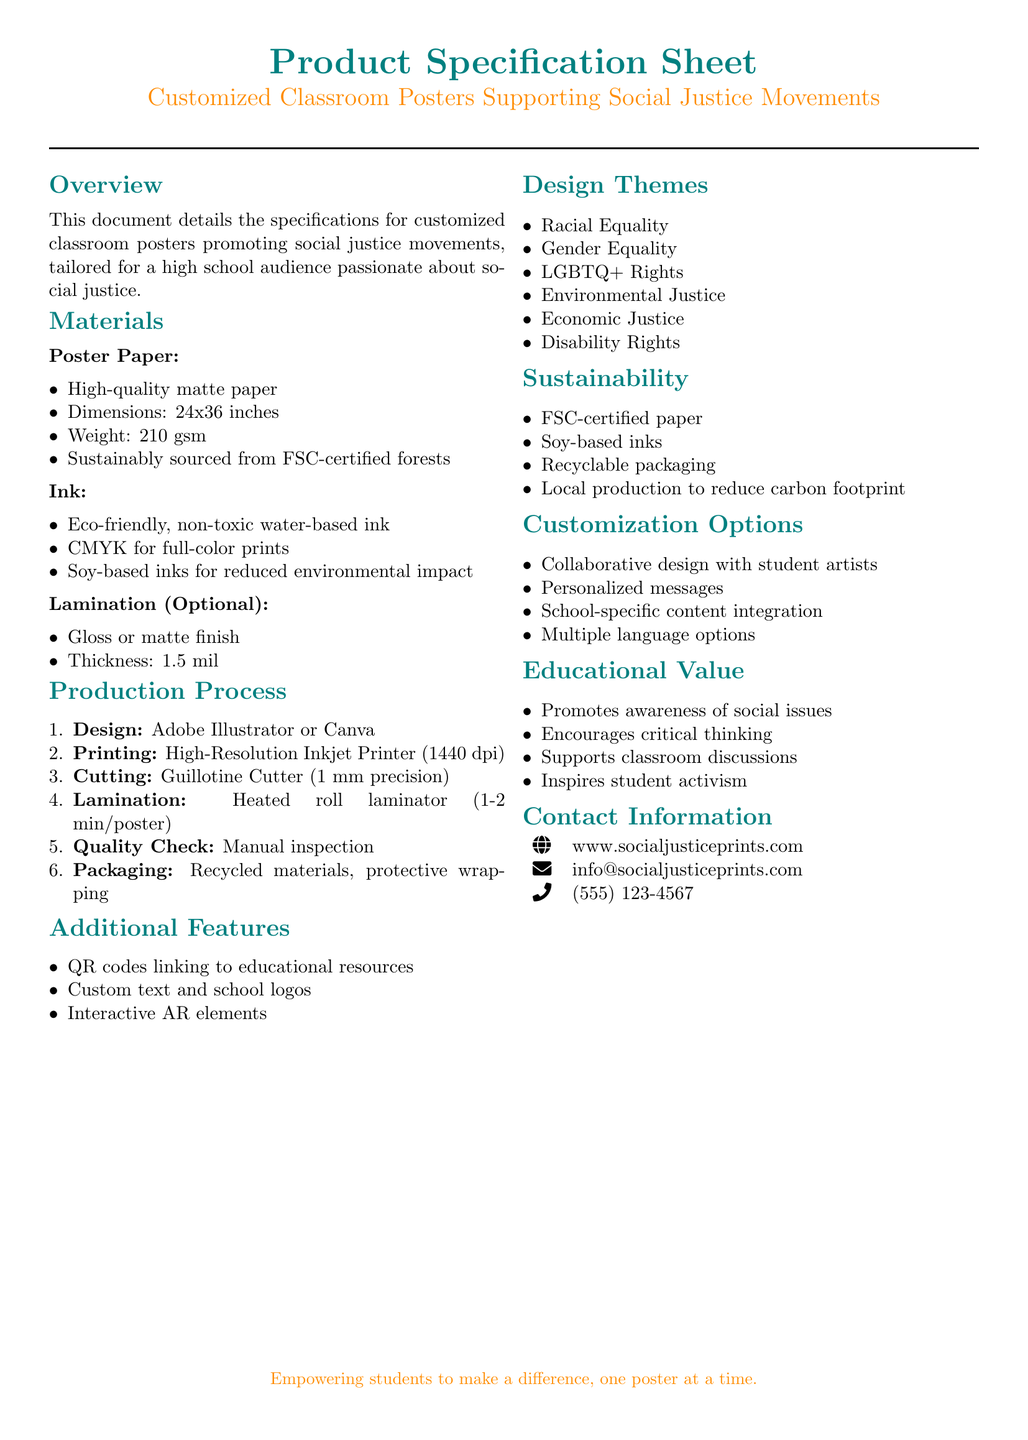what are the dimensions of the poster paper? The dimensions of the poster paper are specified in the document as 24x36 inches.
Answer: 24x36 inches what type of ink is used for the posters? The ink used for the posters is eco-friendly, non-toxic water-based ink.
Answer: eco-friendly, non-toxic water-based ink what is the weight of the poster paper? The weight of the poster paper is mentioned as 210 gsm in the specifications.
Answer: 210 gsm which production process ensures high-quality printing? The production process involving a high-resolution inkjet printer with a resolution of 1440 dpi ensures high-quality printing.
Answer: high-resolution inkjet printer (1440 dpi) what is an optional feature for the posters? One optional feature for the posters is lamination, which can provide a gloss or matte finish.
Answer: lamination how many design themes are listed in the document? The document lists six design themes that focus on various social justice issues.
Answer: six what kind of paper is the poster paper sourced from? The poster paper is sustainably sourced from FSC-certified forests.
Answer: FSC-certified forests name one customization option for the posters. One customization option for the posters is collaborative design with student artists.
Answer: collaborative design with student artists what is the purpose of the posters as stated in the educational value section? The purpose of the posters is to promote awareness of social issues among students.
Answer: promote awareness of social issues 